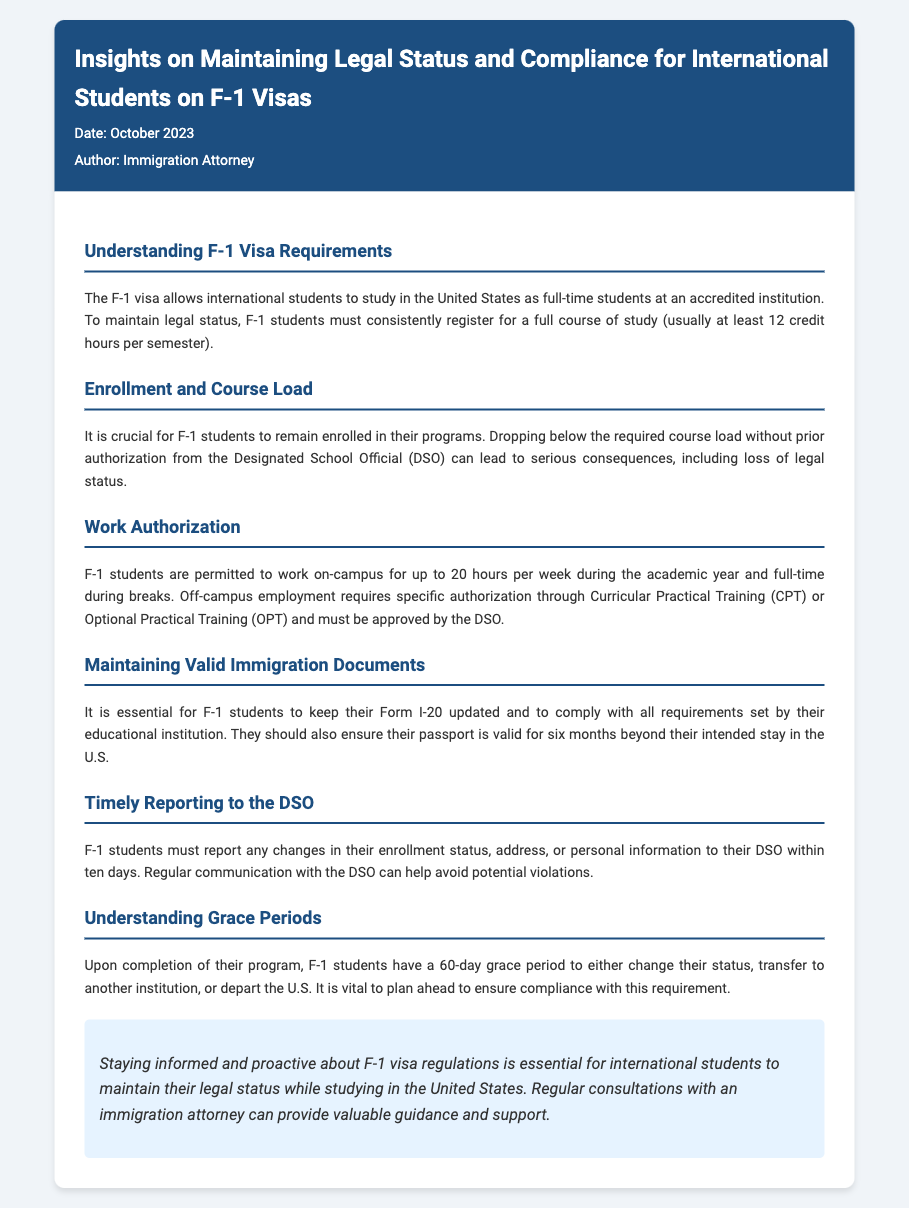What is the minimum course load for F-1 students? The document specifies that F-1 students must register for at least 12 credit hours per semester to maintain legal status.
Answer: 12 credit hours What must F-1 students do to work off-campus? According to the memo, off-campus employment for F-1 students requires specific authorization through Curricular Practical Training (CPT) or Optional Practical Training (OPT) and must be approved by the DSO.
Answer: Authorization through CPT or OPT What is the grace period duration for F-1 students after completing their program? The document states that F-1 students have a 60-day grace period after program completion to change their status, transfer, or depart the U.S.
Answer: 60 days How soon must changes in personal information be reported to the DSO? F-1 students are required to report any changes in their personal information to their DSO within ten days, as noted in the memo.
Answer: Ten days What is essential for maintaining valid immigration documents? The memo mentions that it is essential for F-1 students to keep their Form I-20 updated and comply with all requirements set by their educational institution.
Answer: Keep Form I-20 updated What is one consequence of dropping below the required course load? The document warns that dropping below the required course load without prior authorization can lead to serious consequences, including loss of legal status.
Answer: Loss of legal status Who can provide valuable guidance for F-1 visa regulations? The conclusion of the memo suggests that regular consultations with an immigration attorney can provide valuable guidance and support for F-1 students.
Answer: Immigration attorney What two types of employment can F-1 students engage in without prior authorization? The document states that F-1 students are allowed to work on-campus during the academic year and full-time during breaks without needing prior authorization.
Answer: On-campus work What date is mentioned in the memo? The date noted in the memo indicates when it was authored, providing context for the information shared.
Answer: October 2023 